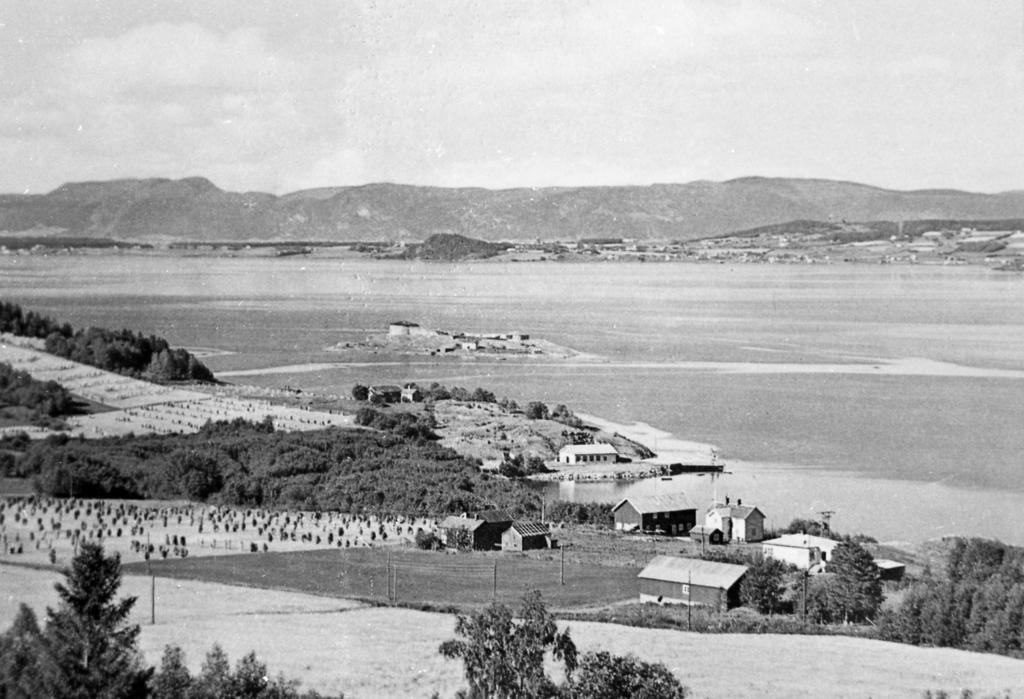What type of structures are present in the image? There are sheds in the image. What type of vegetation can be seen in the image? There are trees in the image. What are the tall, thin objects in the image? There are poles in the image. What can be seen in the distance in the image? There is a hill visible in the background of the image. What is at the bottom of the image? There is water and ground at the bottom of the image. What is the texture of the yam in the image? There is no yam present in the image. How does the soap interact with the water in the image? There is no soap present in the image. 